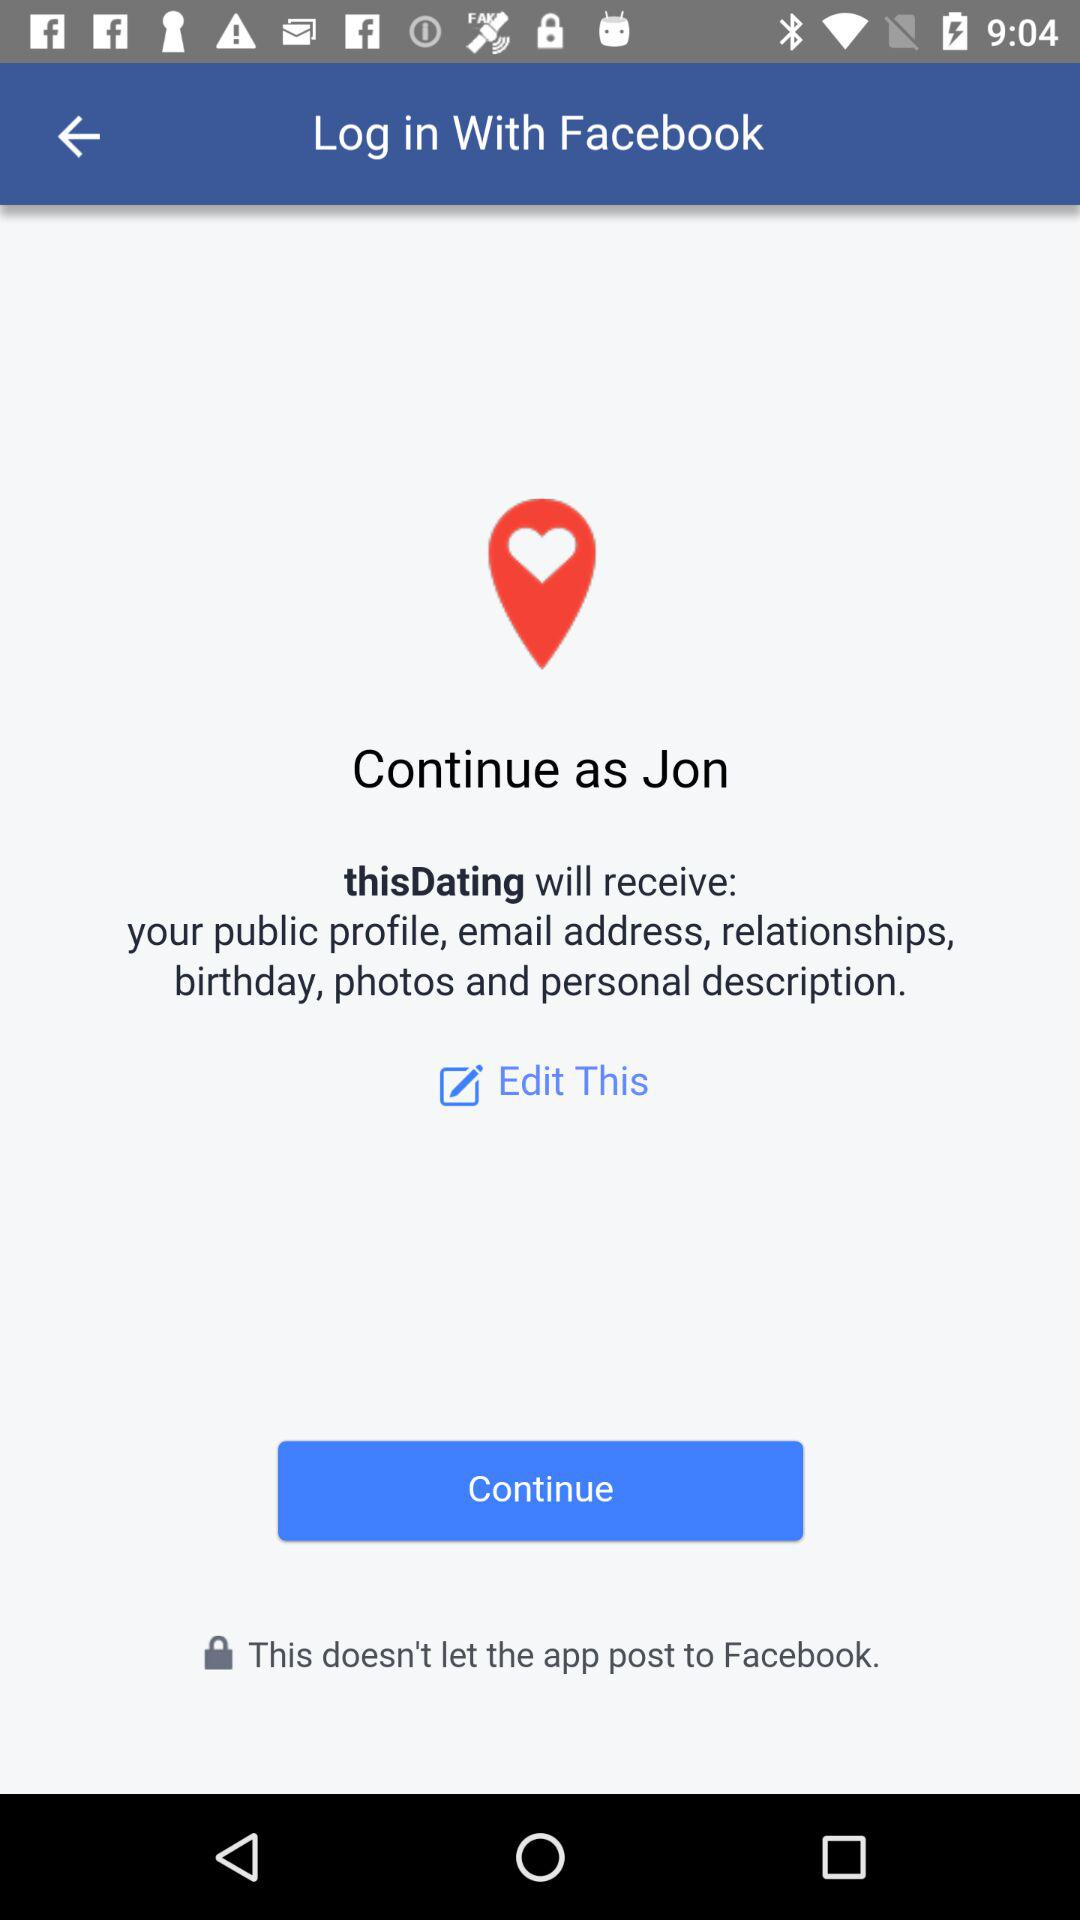What is the user name to continue the profile? The user name is Jon. 